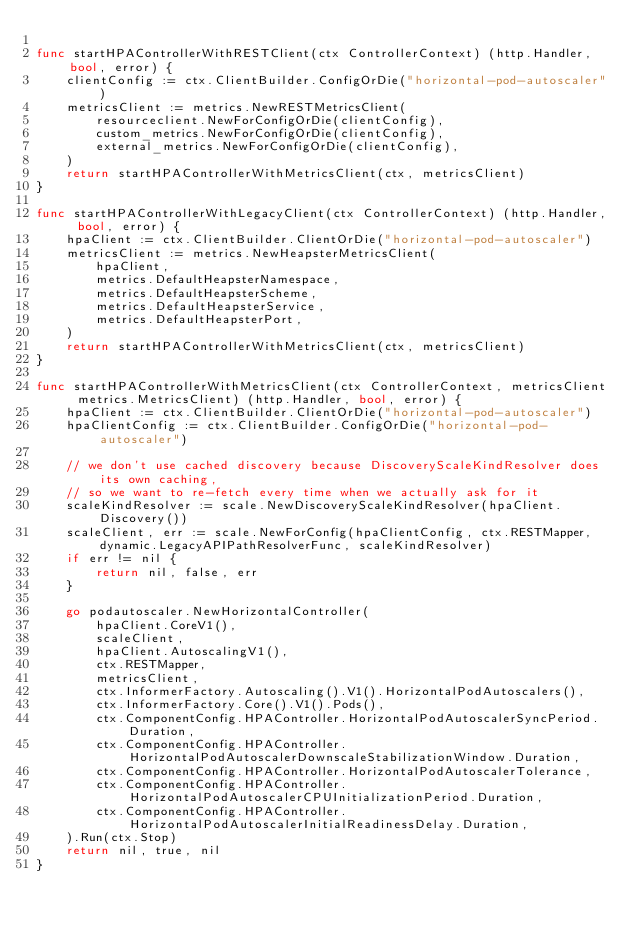<code> <loc_0><loc_0><loc_500><loc_500><_Go_>
func startHPAControllerWithRESTClient(ctx ControllerContext) (http.Handler, bool, error) {
	clientConfig := ctx.ClientBuilder.ConfigOrDie("horizontal-pod-autoscaler")
	metricsClient := metrics.NewRESTMetricsClient(
		resourceclient.NewForConfigOrDie(clientConfig),
		custom_metrics.NewForConfigOrDie(clientConfig),
		external_metrics.NewForConfigOrDie(clientConfig),
	)
	return startHPAControllerWithMetricsClient(ctx, metricsClient)
}

func startHPAControllerWithLegacyClient(ctx ControllerContext) (http.Handler, bool, error) {
	hpaClient := ctx.ClientBuilder.ClientOrDie("horizontal-pod-autoscaler")
	metricsClient := metrics.NewHeapsterMetricsClient(
		hpaClient,
		metrics.DefaultHeapsterNamespace,
		metrics.DefaultHeapsterScheme,
		metrics.DefaultHeapsterService,
		metrics.DefaultHeapsterPort,
	)
	return startHPAControllerWithMetricsClient(ctx, metricsClient)
}

func startHPAControllerWithMetricsClient(ctx ControllerContext, metricsClient metrics.MetricsClient) (http.Handler, bool, error) {
	hpaClient := ctx.ClientBuilder.ClientOrDie("horizontal-pod-autoscaler")
	hpaClientConfig := ctx.ClientBuilder.ConfigOrDie("horizontal-pod-autoscaler")

	// we don't use cached discovery because DiscoveryScaleKindResolver does its own caching,
	// so we want to re-fetch every time when we actually ask for it
	scaleKindResolver := scale.NewDiscoveryScaleKindResolver(hpaClient.Discovery())
	scaleClient, err := scale.NewForConfig(hpaClientConfig, ctx.RESTMapper, dynamic.LegacyAPIPathResolverFunc, scaleKindResolver)
	if err != nil {
		return nil, false, err
	}

	go podautoscaler.NewHorizontalController(
		hpaClient.CoreV1(),
		scaleClient,
		hpaClient.AutoscalingV1(),
		ctx.RESTMapper,
		metricsClient,
		ctx.InformerFactory.Autoscaling().V1().HorizontalPodAutoscalers(),
		ctx.InformerFactory.Core().V1().Pods(),
		ctx.ComponentConfig.HPAController.HorizontalPodAutoscalerSyncPeriod.Duration,
		ctx.ComponentConfig.HPAController.HorizontalPodAutoscalerDownscaleStabilizationWindow.Duration,
		ctx.ComponentConfig.HPAController.HorizontalPodAutoscalerTolerance,
		ctx.ComponentConfig.HPAController.HorizontalPodAutoscalerCPUInitializationPeriod.Duration,
		ctx.ComponentConfig.HPAController.HorizontalPodAutoscalerInitialReadinessDelay.Duration,
	).Run(ctx.Stop)
	return nil, true, nil
}
</code> 